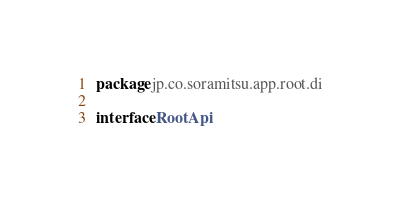<code> <loc_0><loc_0><loc_500><loc_500><_Kotlin_>package jp.co.soramitsu.app.root.di

interface RootApi</code> 